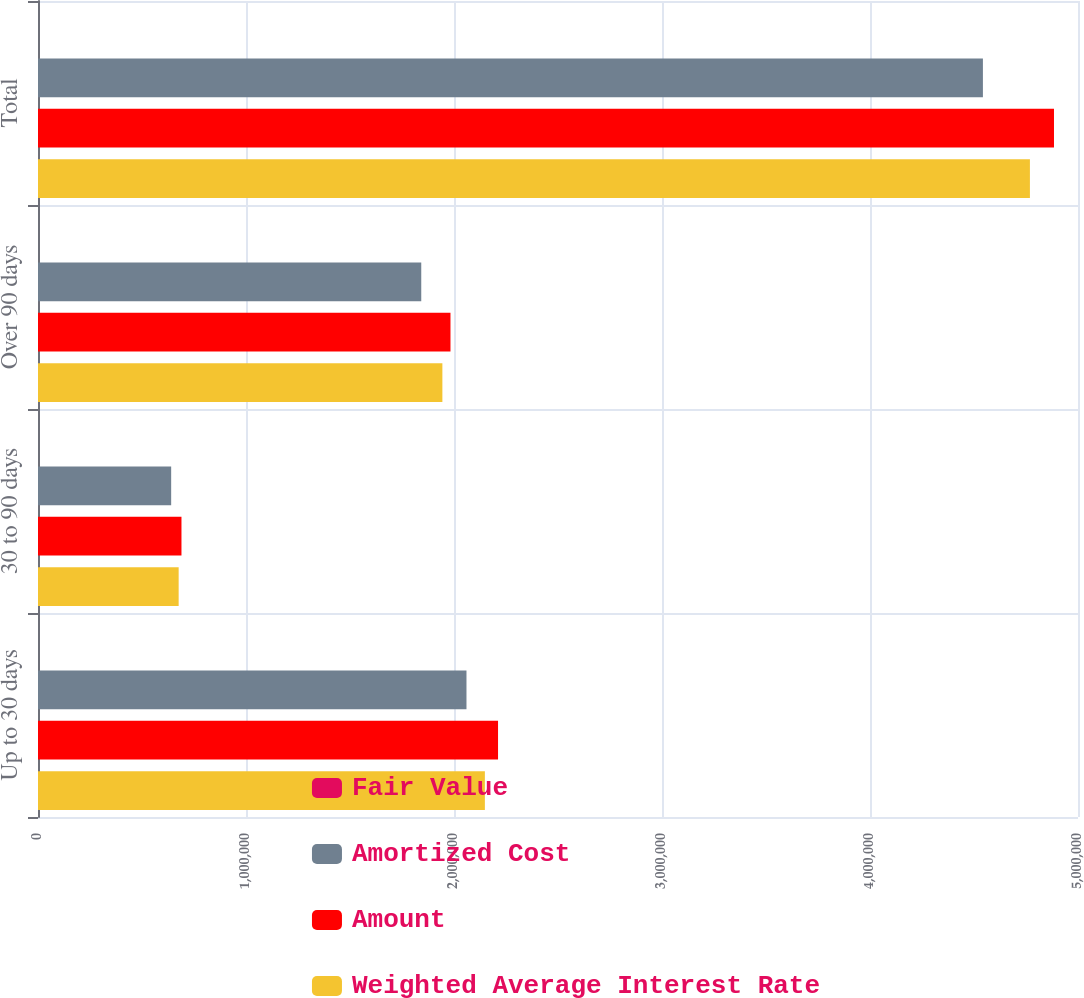Convert chart. <chart><loc_0><loc_0><loc_500><loc_500><stacked_bar_chart><ecel><fcel>Up to 30 days<fcel>30 to 90 days<fcel>Over 90 days<fcel>Total<nl><fcel>Fair Value<fcel>0.3<fcel>0.36<fcel>0.96<fcel>0.57<nl><fcel>Amortized Cost<fcel>2.06001e+06<fcel>640248<fcel>1.84258e+06<fcel>4.54284e+06<nl><fcel>Amount<fcel>2.21173e+06<fcel>689765<fcel>1.98308e+06<fcel>4.88457e+06<nl><fcel>Weighted Average Interest Rate<fcel>2.14845e+06<fcel>676224<fcel>1.94414e+06<fcel>4.76882e+06<nl></chart> 